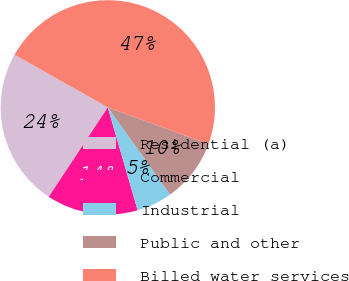<chart> <loc_0><loc_0><loc_500><loc_500><pie_chart><fcel>Residential (a)<fcel>Commercial<fcel>Industrial<fcel>Public and other<fcel>Billed water services<nl><fcel>23.89%<fcel>13.78%<fcel>5.38%<fcel>9.58%<fcel>47.38%<nl></chart> 